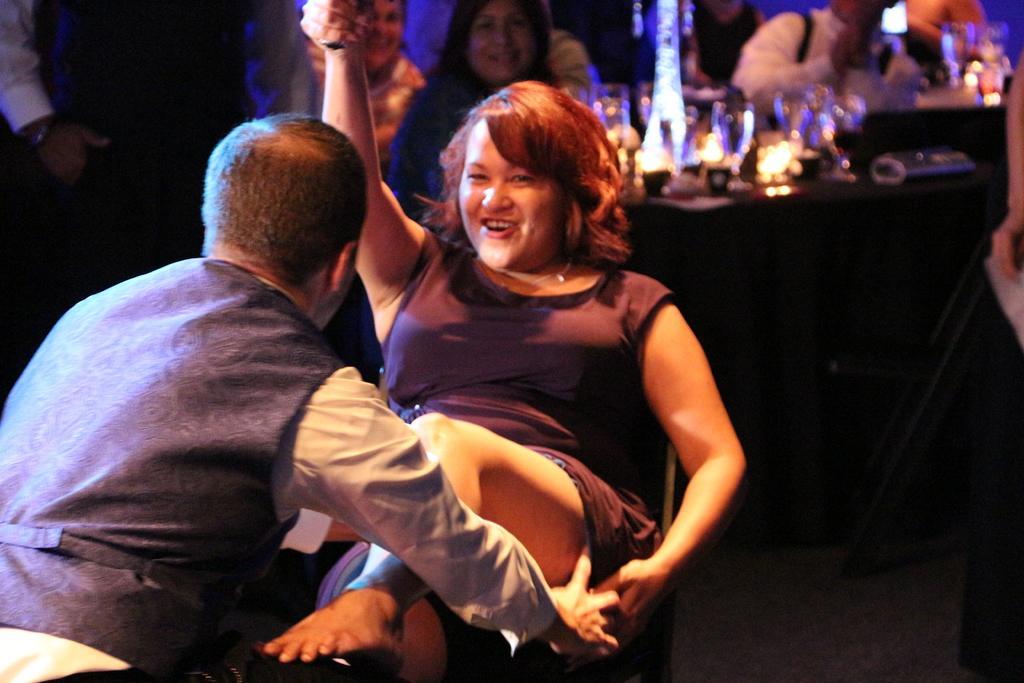Can you describe this image briefly? In this image I can see number of people, few glasses and I can see this image is little bit blurry from background. 